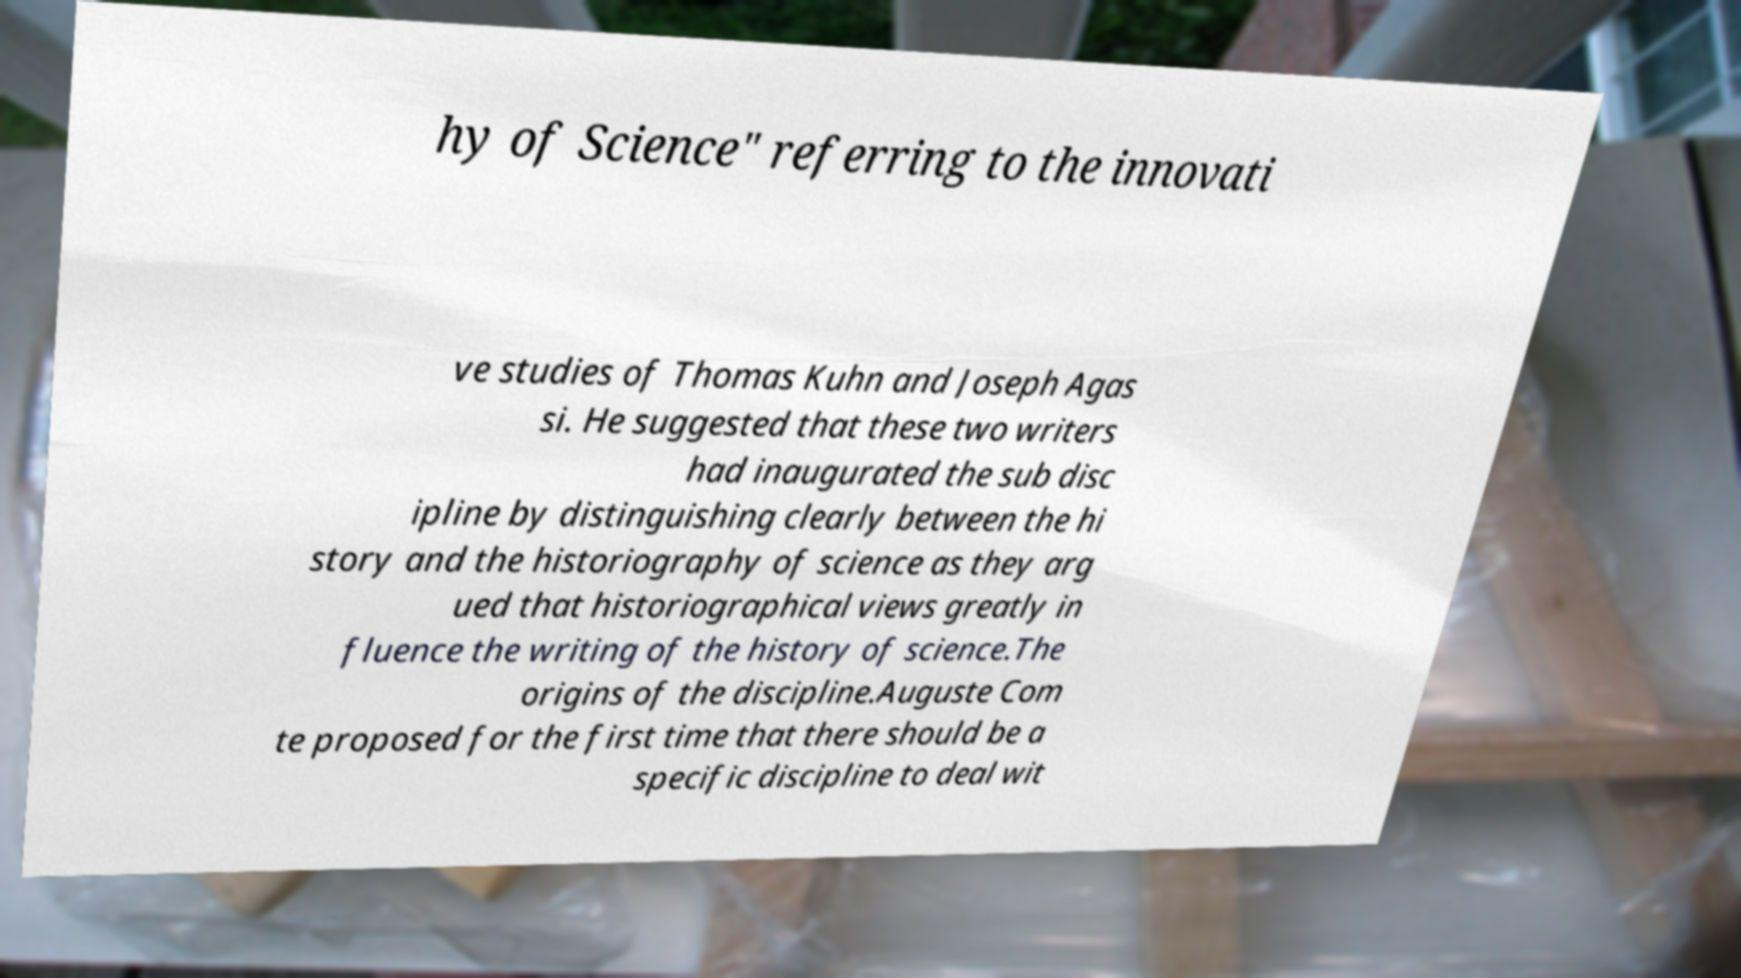Can you read and provide the text displayed in the image?This photo seems to have some interesting text. Can you extract and type it out for me? hy of Science" referring to the innovati ve studies of Thomas Kuhn and Joseph Agas si. He suggested that these two writers had inaugurated the sub disc ipline by distinguishing clearly between the hi story and the historiography of science as they arg ued that historiographical views greatly in fluence the writing of the history of science.The origins of the discipline.Auguste Com te proposed for the first time that there should be a specific discipline to deal wit 